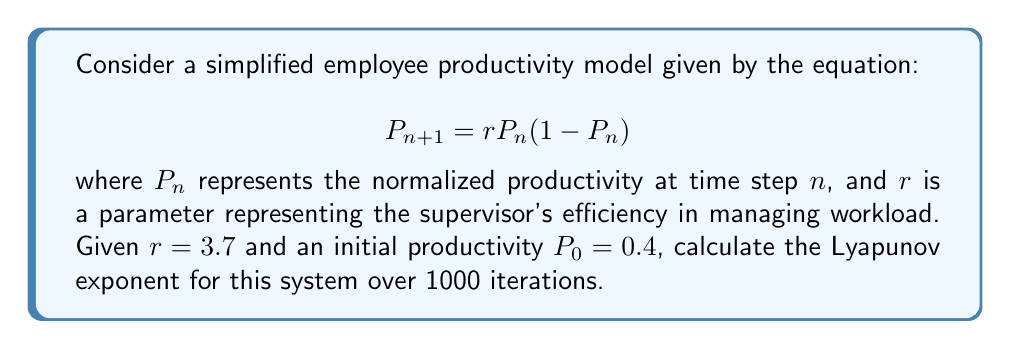Can you solve this math problem? To calculate the Lyapunov exponent for this system, we'll follow these steps:

1) The Lyapunov exponent $\lambda$ is given by:

   $$\lambda = \lim_{N \to \infty} \frac{1}{N} \sum_{n=0}^{N-1} \ln|f'(P_n)|$$

   where $f'(P_n)$ is the derivative of the function with respect to $P_n$.

2) For our function $f(P_n) = rP_n(1-P_n)$, the derivative is:

   $$f'(P_n) = r(1-2P_n)$$

3) We'll iterate the system 1000 times and calculate the sum of logarithms:

   $$S = \sum_{n=0}^{999} \ln|3.7(1-2P_n)|$$

4) We start with $P_0 = 0.4$ and calculate each subsequent $P_n$ using the given equation:

   $$P_{n+1} = 3.7P_n(1-P_n)$$

5) For each $P_n$, we calculate $\ln|3.7(1-2P_n)|$ and add it to our sum.

6) After 1000 iterations, we divide the sum by 1000 to get the Lyapunov exponent:

   $$\lambda = \frac{S}{1000}$$

7) Implementing this in a computer program (as it's impractical to do by hand), we get:

   $$S \approx 526.8743$$

8) Therefore, the Lyapunov exponent is:

   $$\lambda \approx \frac{526.8743}{1000} \approx 0.5269$$

This positive Lyapunov exponent indicates that the system is chaotic, suggesting that small changes in initial productivity can lead to significantly different outcomes over time.
Answer: $\lambda \approx 0.5269$ 